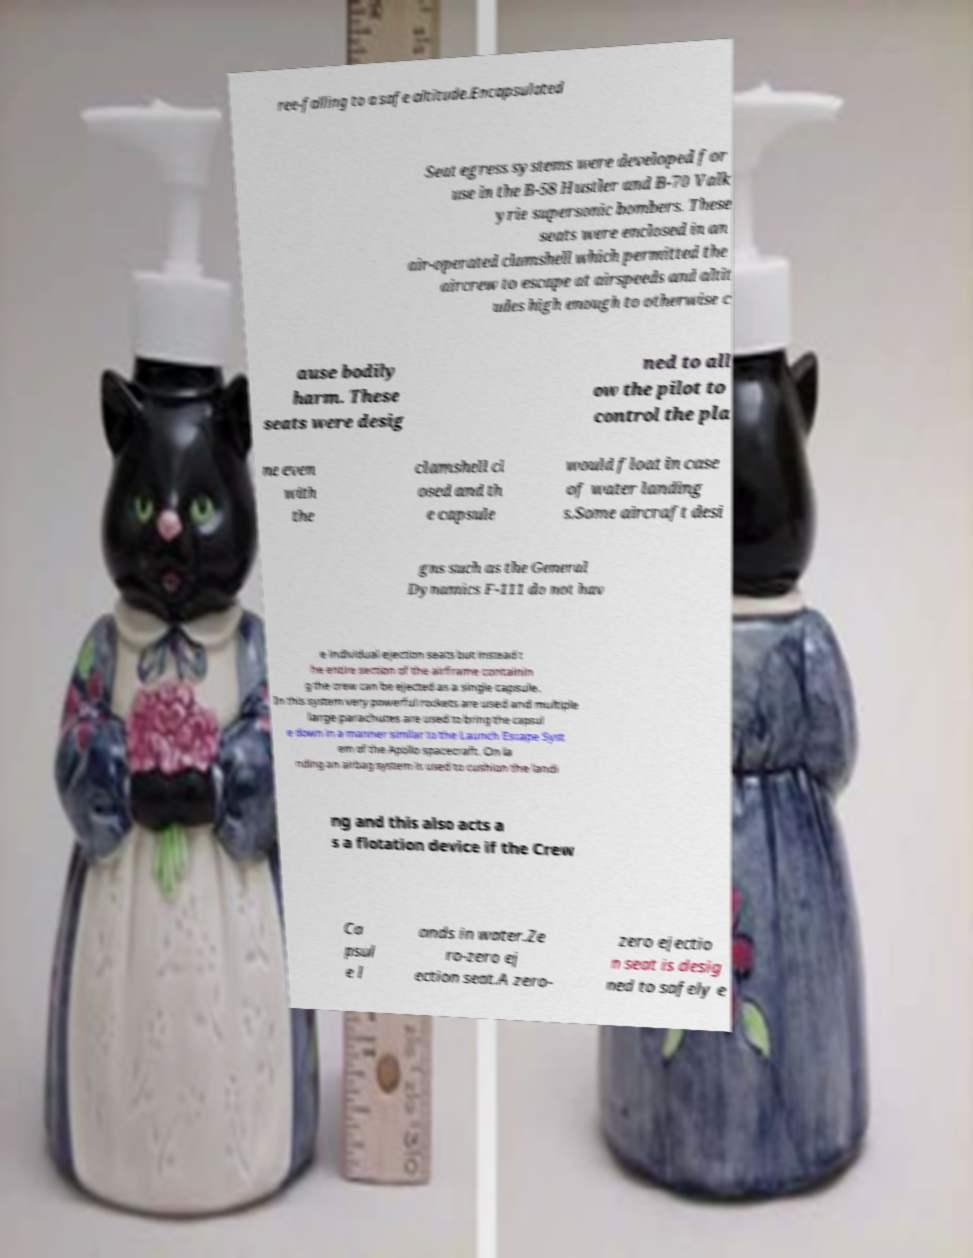Could you extract and type out the text from this image? ree-falling to a safe altitude.Encapsulated Seat egress systems were developed for use in the B-58 Hustler and B-70 Valk yrie supersonic bombers. These seats were enclosed in an air-operated clamshell which permitted the aircrew to escape at airspeeds and altit udes high enough to otherwise c ause bodily harm. These seats were desig ned to all ow the pilot to control the pla ne even with the clamshell cl osed and th e capsule would float in case of water landing s.Some aircraft desi gns such as the General Dynamics F-111 do not hav e individual ejection seats but instead t he entire section of the airframe containin g the crew can be ejected as a single capsule. In this system very powerful rockets are used and multiple large parachutes are used to bring the capsul e down in a manner similar to the Launch Escape Syst em of the Apollo spacecraft. On la nding an airbag system is used to cushion the landi ng and this also acts a s a flotation device if the Crew Ca psul e l ands in water.Ze ro-zero ej ection seat.A zero- zero ejectio n seat is desig ned to safely e 